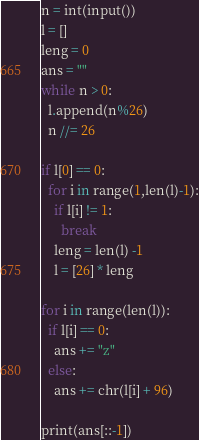<code> <loc_0><loc_0><loc_500><loc_500><_Python_>n = int(input())
l = []
leng = 0
ans = ""
while n > 0:
  l.append(n%26)
  n //= 26

if l[0] == 0:
  for i in range(1,len(l)-1):
    if l[i] != 1:
      break
    leng = len(l) -1
    l = [26] * leng
  
for i in range(len(l)):
  if l[i] == 0:
    ans += "z"
  else:
    ans += chr(l[i] + 96)

print(ans[::-1])</code> 